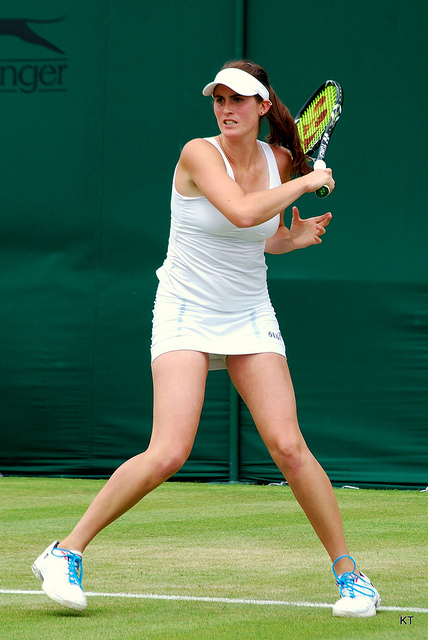Please transcribe the text information in this image. nger KT 